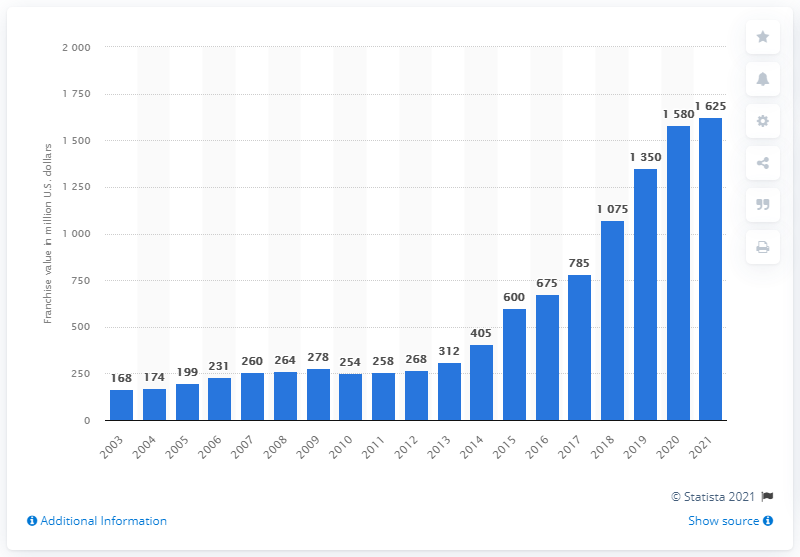Indicate a few pertinent items in this graphic. The estimated value of the Milwaukee Bucks in 2021 was approximately $16.25 billion. 